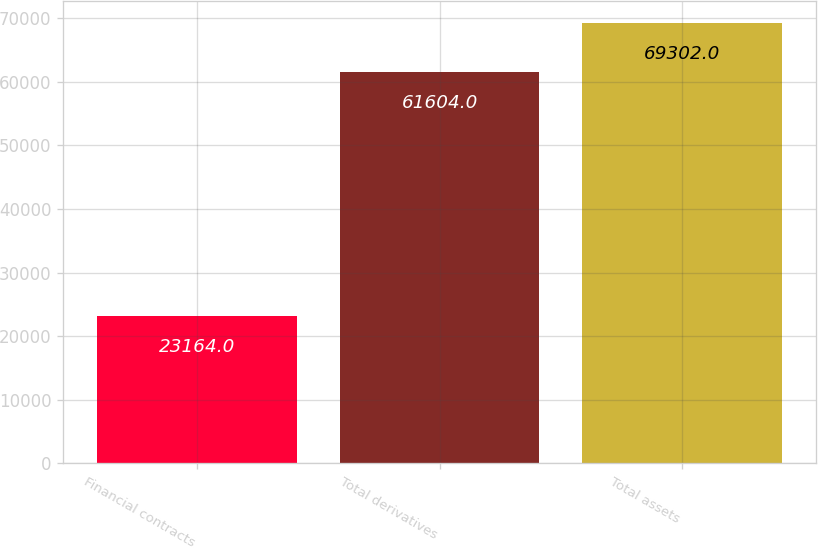<chart> <loc_0><loc_0><loc_500><loc_500><bar_chart><fcel>Financial contracts<fcel>Total derivatives<fcel>Total assets<nl><fcel>23164<fcel>61604<fcel>69302<nl></chart> 